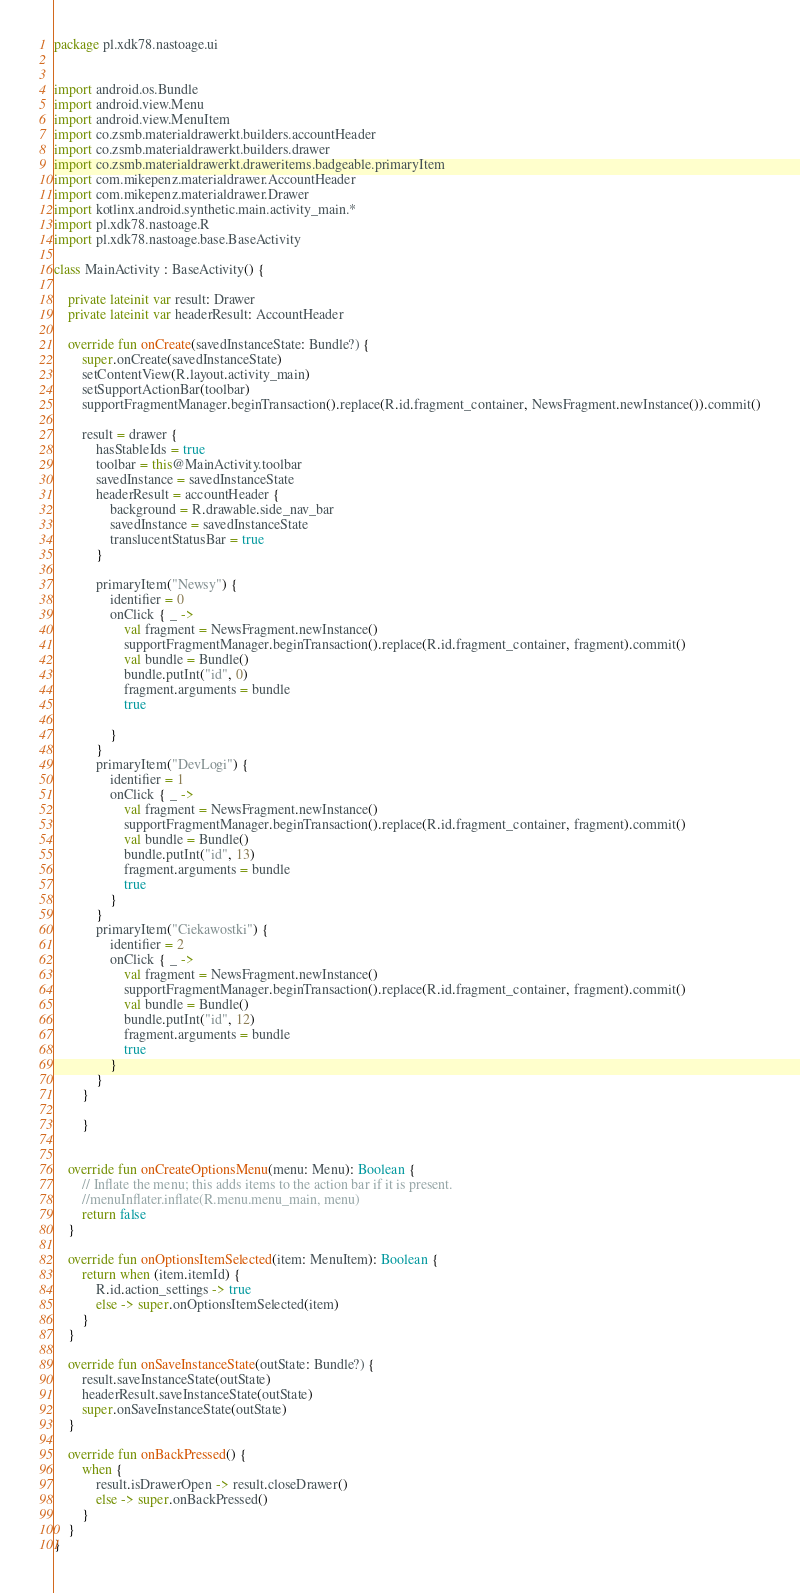Convert code to text. <code><loc_0><loc_0><loc_500><loc_500><_Kotlin_>package pl.xdk78.nastoage.ui


import android.os.Bundle
import android.view.Menu
import android.view.MenuItem
import co.zsmb.materialdrawerkt.builders.accountHeader
import co.zsmb.materialdrawerkt.builders.drawer
import co.zsmb.materialdrawerkt.draweritems.badgeable.primaryItem
import com.mikepenz.materialdrawer.AccountHeader
import com.mikepenz.materialdrawer.Drawer
import kotlinx.android.synthetic.main.activity_main.*
import pl.xdk78.nastoage.R
import pl.xdk78.nastoage.base.BaseActivity

class MainActivity : BaseActivity() {

    private lateinit var result: Drawer
    private lateinit var headerResult: AccountHeader

    override fun onCreate(savedInstanceState: Bundle?) {
        super.onCreate(savedInstanceState)
        setContentView(R.layout.activity_main)
        setSupportActionBar(toolbar)
        supportFragmentManager.beginTransaction().replace(R.id.fragment_container, NewsFragment.newInstance()).commit()

        result = drawer {
            hasStableIds = true
            toolbar = this@MainActivity.toolbar
            savedInstance = savedInstanceState
            headerResult = accountHeader {
                background = R.drawable.side_nav_bar
                savedInstance = savedInstanceState
                translucentStatusBar = true
            }

            primaryItem("Newsy") {
                identifier = 0
                onClick { _ ->
                    val fragment = NewsFragment.newInstance()
                    supportFragmentManager.beginTransaction().replace(R.id.fragment_container, fragment).commit()
                    val bundle = Bundle()
                    bundle.putInt("id", 0)
                    fragment.arguments = bundle
                    true

                }
            }
            primaryItem("DevLogi") {
                identifier = 1
                onClick { _ ->
                    val fragment = NewsFragment.newInstance()
                    supportFragmentManager.beginTransaction().replace(R.id.fragment_container, fragment).commit()
                    val bundle = Bundle()
                    bundle.putInt("id", 13)
                    fragment.arguments = bundle
                    true
                }
            }
            primaryItem("Ciekawostki") {
                identifier = 2
                onClick { _ ->
                    val fragment = NewsFragment.newInstance()
                    supportFragmentManager.beginTransaction().replace(R.id.fragment_container, fragment).commit()
                    val bundle = Bundle()
                    bundle.putInt("id", 12)
                    fragment.arguments = bundle
                    true
                }
            }
        }

        }


    override fun onCreateOptionsMenu(menu: Menu): Boolean {
        // Inflate the menu; this adds items to the action bar if it is present.
        //menuInflater.inflate(R.menu.menu_main, menu)
        return false
    }

    override fun onOptionsItemSelected(item: MenuItem): Boolean {
        return when (item.itemId) {
            R.id.action_settings -> true
            else -> super.onOptionsItemSelected(item)
        }
    }

    override fun onSaveInstanceState(outState: Bundle?) {
        result.saveInstanceState(outState)
        headerResult.saveInstanceState(outState)
        super.onSaveInstanceState(outState)
    }

    override fun onBackPressed() {
        when {
            result.isDrawerOpen -> result.closeDrawer()
            else -> super.onBackPressed()
        }
    }
}




</code> 